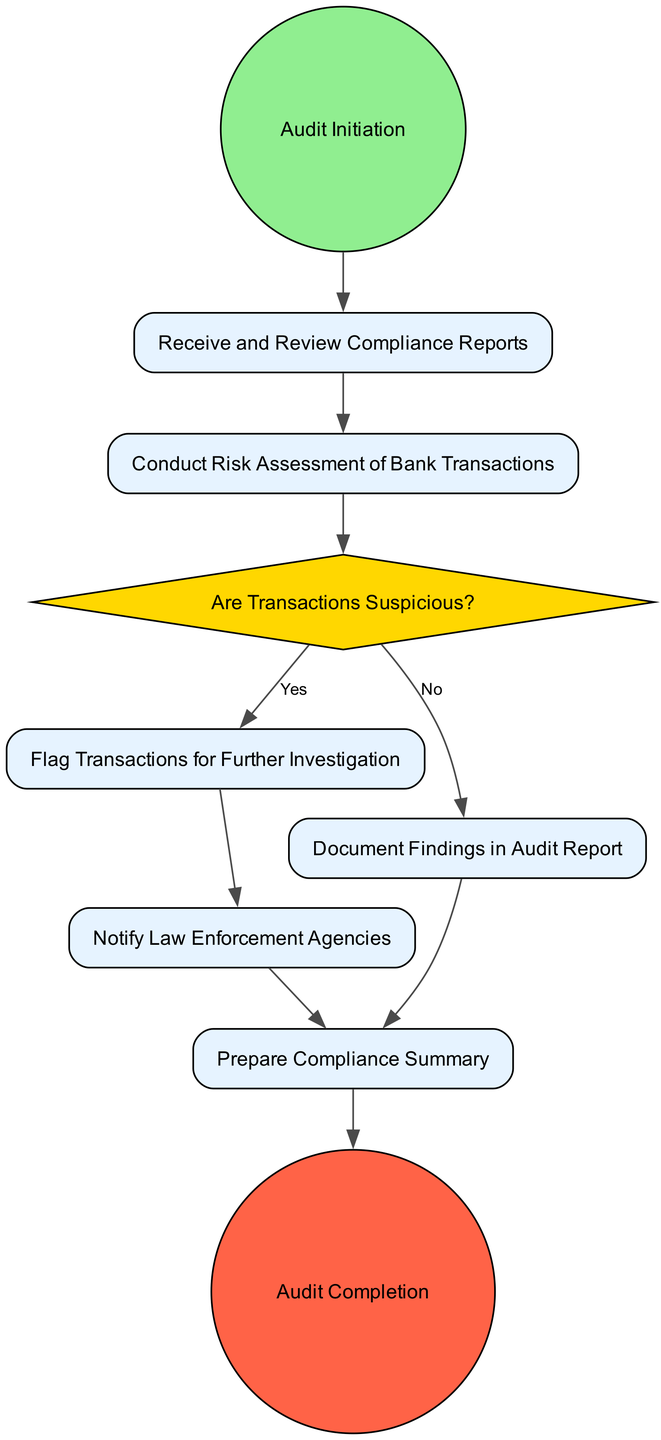What is the first activity in the diagram? The first activity is labeled as "Receive and Review Compliance Reports," which directly follows the "Audit Initiation" start event, marking the beginning of the workflow.
Answer: Receive and Review Compliance Reports How many decision points are in the diagram? There is one decision point labeled "Are Transactions Suspicious?" which branches into different activities based on whether the transactions are flagged as suspicious or not.
Answer: 1 What activity follows "Notify Law Enforcement Agencies"? The next activity after "Notify Law Enforcement Agencies" is "Prepare Compliance Summary." This is due to the directed edge leading from the former to the latter in the diagram.
Answer: Prepare Compliance Summary From which activity does the "Flag Transactions for Further Investigation" arise? The "Flag Transactions for Further Investigation" activity arises from the decision point "Are Transactions Suspicious?" based on a 'Yes' condition leading to the flagging of transactions for further examination.
Answer: Are Transactions Suspicious? How many activities are there in total? The total number of activities is five, which includes "Receive and Review Compliance Reports," "Conduct Risk Assessment of Bank Transactions," "Flag Transactions for Further Investigation," "Document Findings in Audit Report," and "Prepare Compliance Summary."
Answer: 5 What happens if transactions are not suspicious? If transactions are not suspicious, the workflow leads to the activity "Document Findings in Audit Report," allowing the audit process to continue without flagging any transactions.
Answer: Document Findings in Audit Report What is the final event of the workflow? The final event of the workflow is labeled "Audit Completion," which signifies the end of the process after all necessary activities and decisions have been completed.
Answer: Audit Completion What does a 'Yes' condition lead to in the decision point? A 'Yes' condition leads to the activity "Flag Transactions for Further Investigation," indicating that suspicious transactions require additional scrutiny and reporting.
Answer: Flag Transactions for Further Investigation 